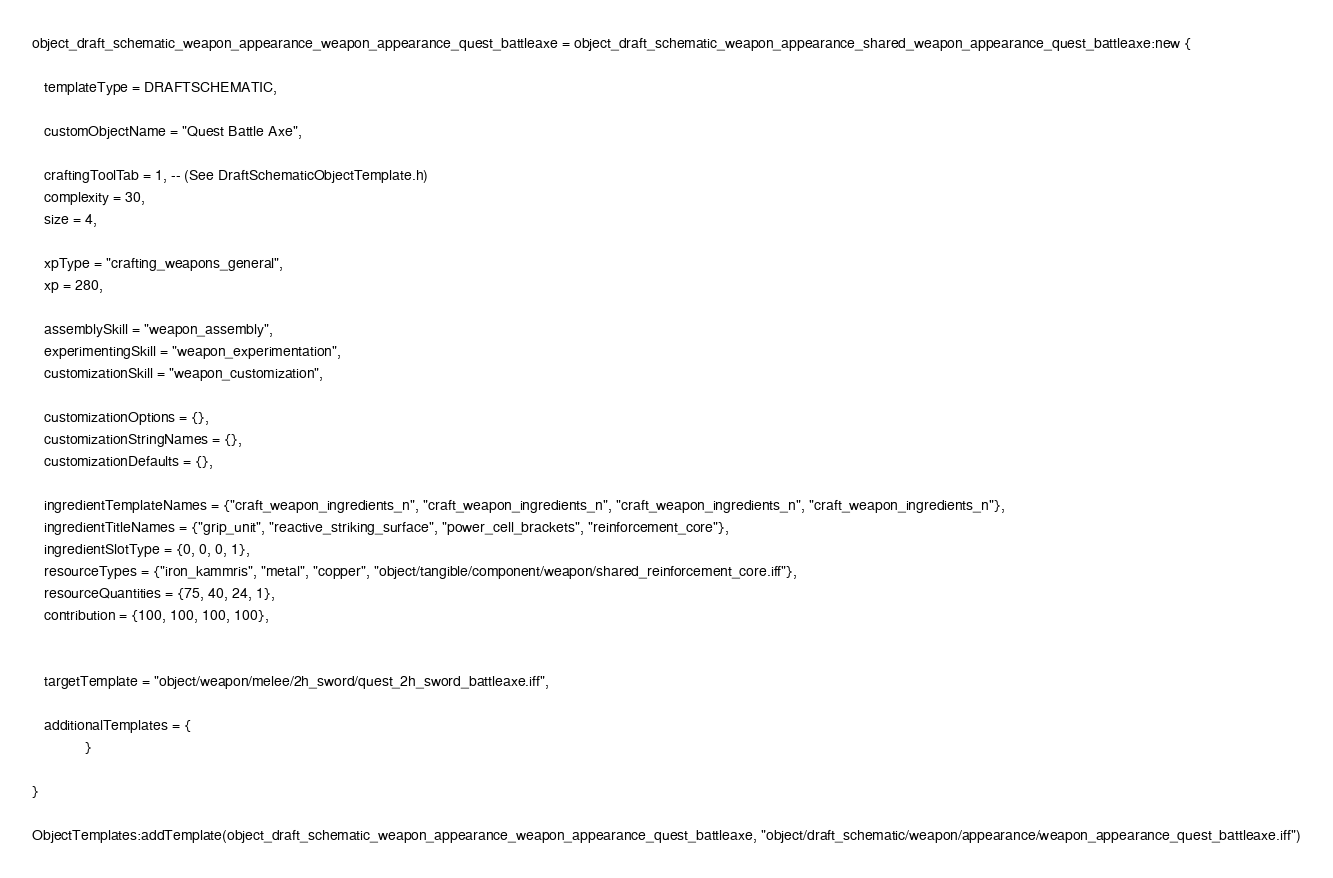Convert code to text. <code><loc_0><loc_0><loc_500><loc_500><_Lua_>object_draft_schematic_weapon_appearance_weapon_appearance_quest_battleaxe = object_draft_schematic_weapon_appearance_shared_weapon_appearance_quest_battleaxe:new {

   templateType = DRAFTSCHEMATIC,

   customObjectName = "Quest Battle Axe",

   craftingToolTab = 1, -- (See DraftSchematicObjectTemplate.h)
   complexity = 30, 
   size = 4, 

   xpType = "crafting_weapons_general", 
   xp = 280, 

   assemblySkill = "weapon_assembly", 
   experimentingSkill = "weapon_experimentation", 
   customizationSkill = "weapon_customization", 

   customizationOptions = {},
   customizationStringNames = {},
   customizationDefaults = {},

   ingredientTemplateNames = {"craft_weapon_ingredients_n", "craft_weapon_ingredients_n", "craft_weapon_ingredients_n", "craft_weapon_ingredients_n"},
   ingredientTitleNames = {"grip_unit", "reactive_striking_surface", "power_cell_brackets", "reinforcement_core"},
   ingredientSlotType = {0, 0, 0, 1},
   resourceTypes = {"iron_kammris", "metal", "copper", "object/tangible/component/weapon/shared_reinforcement_core.iff"},
   resourceQuantities = {75, 40, 24, 1},
   contribution = {100, 100, 100, 100},


   targetTemplate = "object/weapon/melee/2h_sword/quest_2h_sword_battleaxe.iff",

   additionalTemplates = {
             }

}

ObjectTemplates:addTemplate(object_draft_schematic_weapon_appearance_weapon_appearance_quest_battleaxe, "object/draft_schematic/weapon/appearance/weapon_appearance_quest_battleaxe.iff")
</code> 